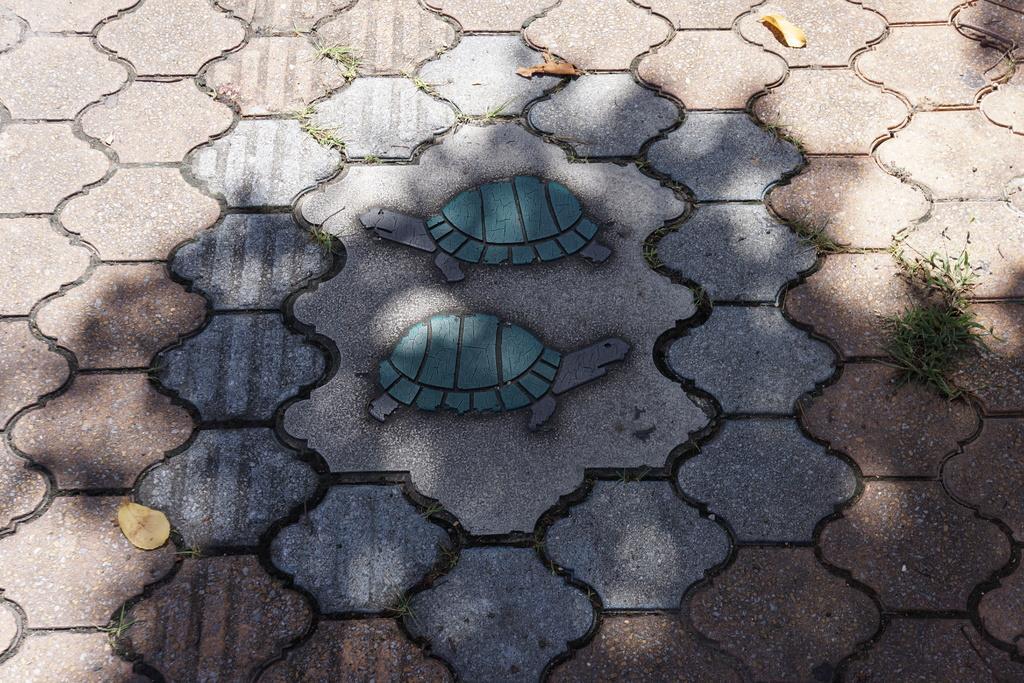Describe this image in one or two sentences. In this image we can see the floor and there are two pictures of tortoise and we can see few dry leaves and we can see the grass. 